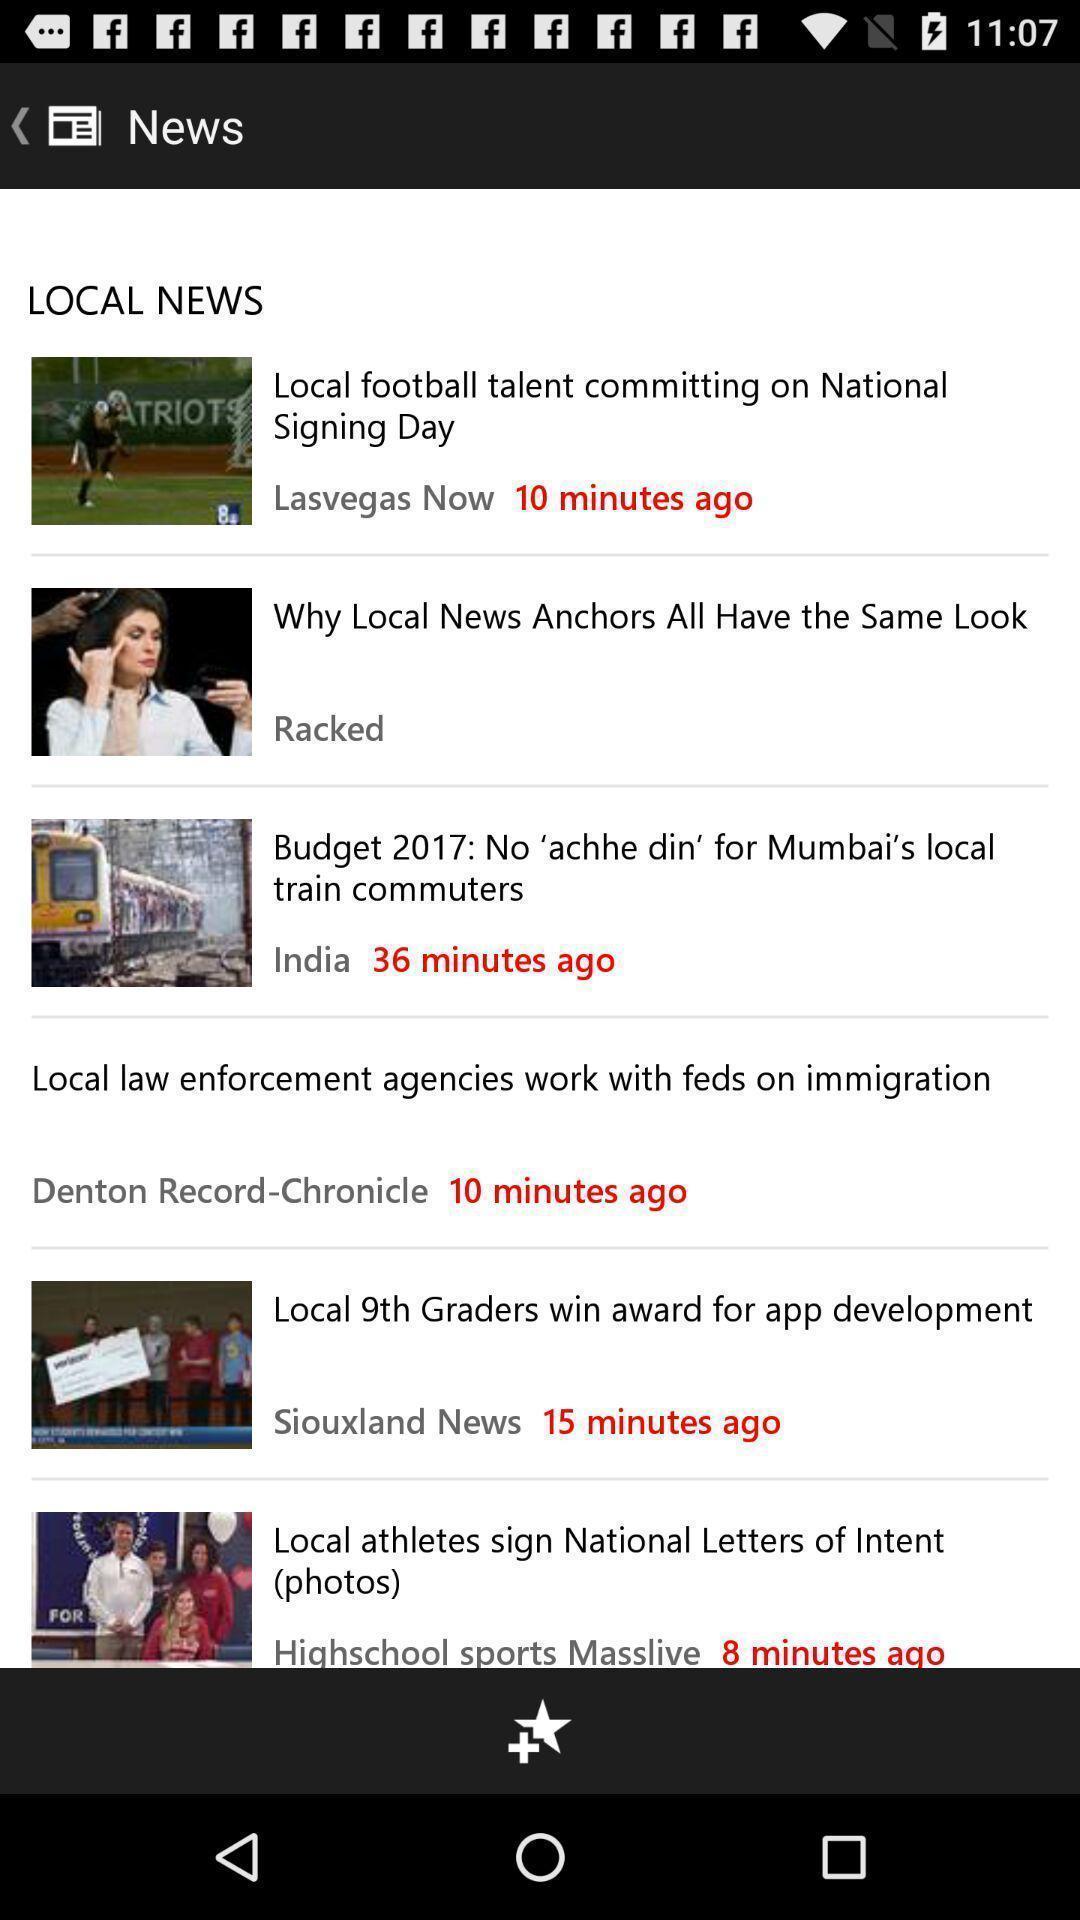Provide a detailed account of this screenshot. Screen shows list of articles in a news app. 